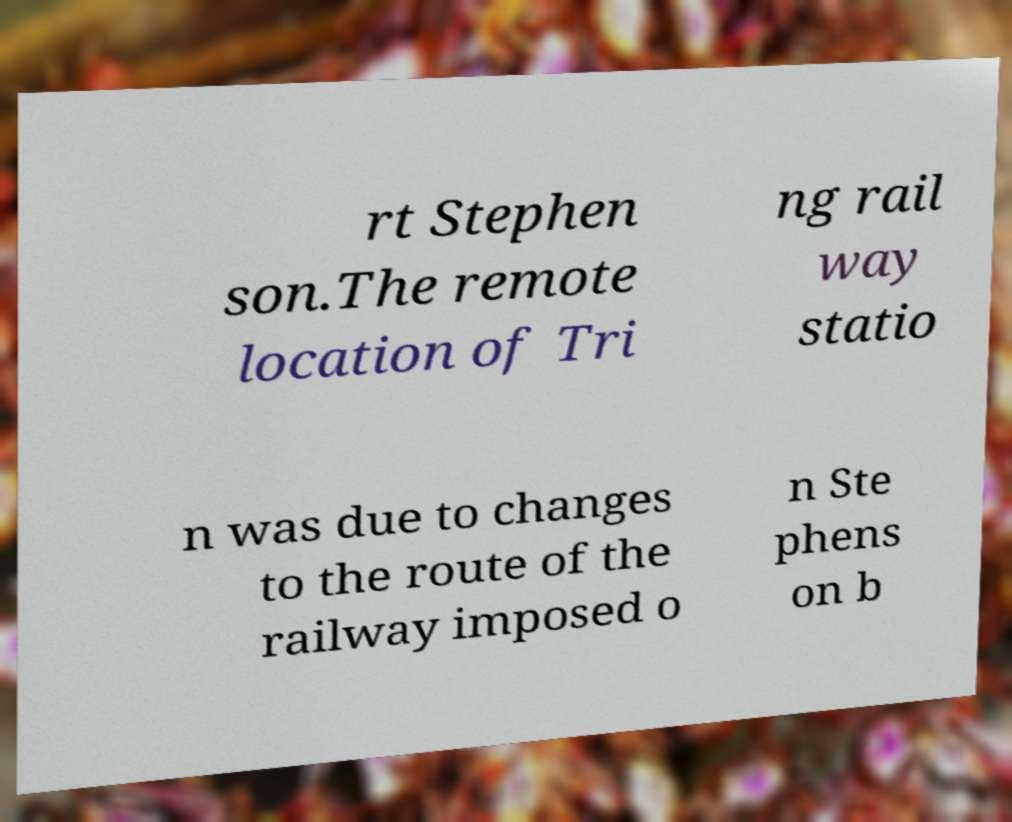For documentation purposes, I need the text within this image transcribed. Could you provide that? rt Stephen son.The remote location of Tri ng rail way statio n was due to changes to the route of the railway imposed o n Ste phens on b 